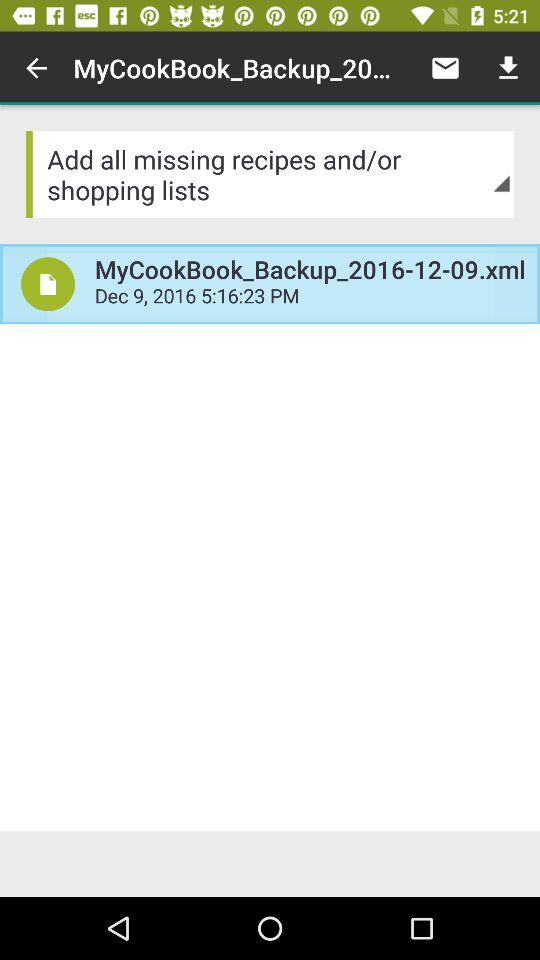What is the time mentioned for the "MyCookBook_Backup_2016-12-09.xml" file? The time mentioned for the "MyCookBook_Backup_2016-12-09.xml" file is 5:16:23 PM. 